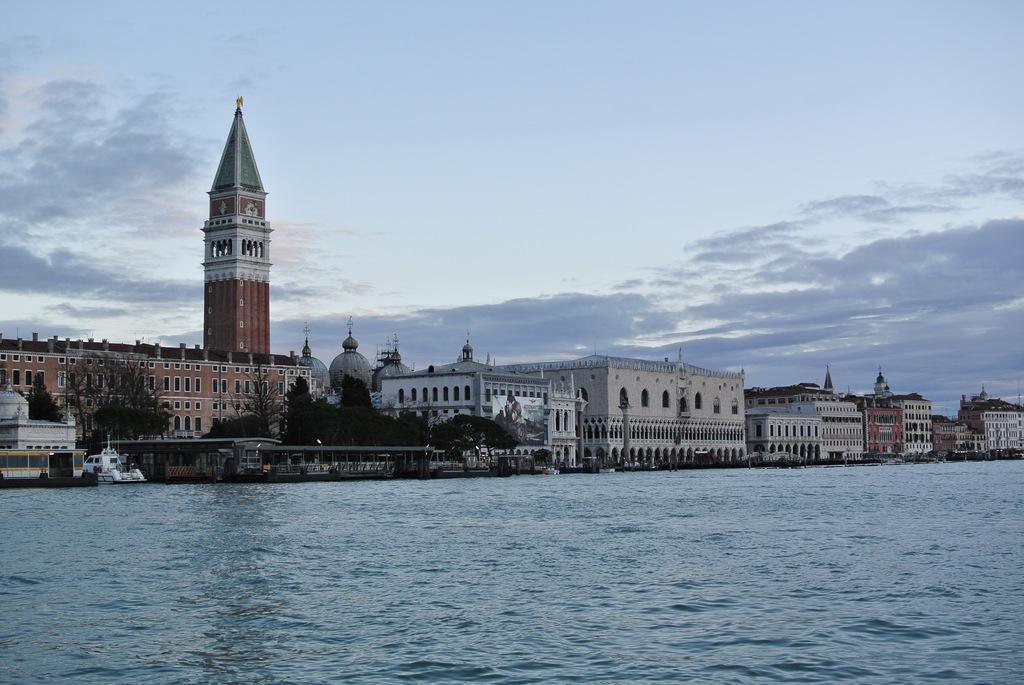Could you give a brief overview of what you see in this image? In the center of the image there are buildings and trees. At the bottom there is water and we can see vehicles on the road. In the background there is sky. 